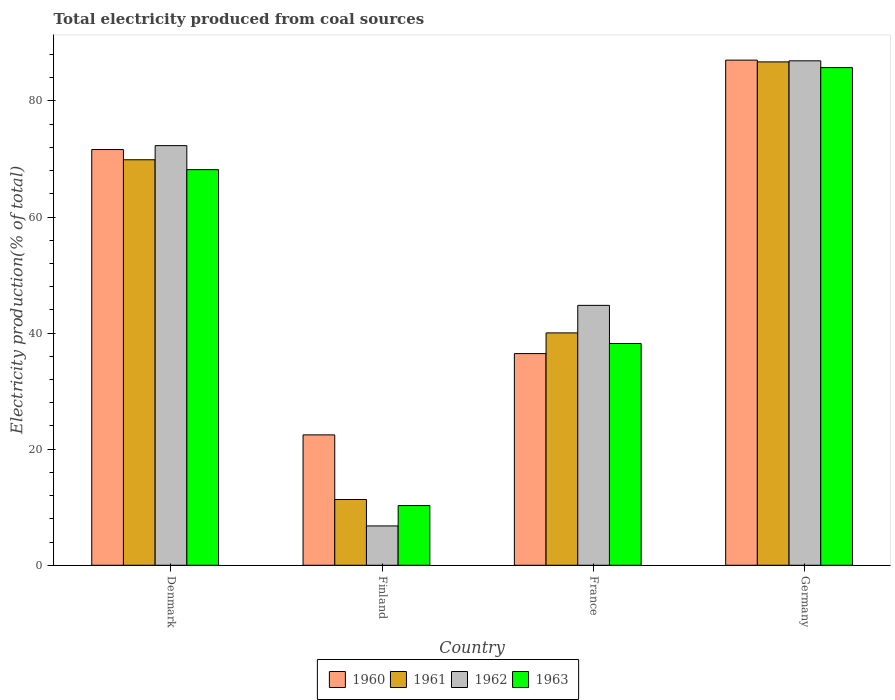How many bars are there on the 4th tick from the left?
Offer a terse response. 4. What is the total electricity produced in 1962 in Germany?
Offer a very short reply. 86.91. Across all countries, what is the maximum total electricity produced in 1962?
Ensure brevity in your answer.  86.91. Across all countries, what is the minimum total electricity produced in 1961?
Provide a succinct answer. 11.33. In which country was the total electricity produced in 1960 maximum?
Your response must be concise. Germany. What is the total total electricity produced in 1962 in the graph?
Provide a short and direct response. 210.76. What is the difference between the total electricity produced in 1962 in Denmark and that in Finland?
Your response must be concise. 65.53. What is the difference between the total electricity produced in 1960 in France and the total electricity produced in 1962 in Finland?
Keep it short and to the point. 29.69. What is the average total electricity produced in 1963 per country?
Offer a very short reply. 50.6. What is the difference between the total electricity produced of/in 1960 and total electricity produced of/in 1963 in Finland?
Your answer should be compact. 12.18. What is the ratio of the total electricity produced in 1962 in Denmark to that in Germany?
Provide a short and direct response. 0.83. Is the total electricity produced in 1962 in Denmark less than that in Finland?
Keep it short and to the point. No. Is the difference between the total electricity produced in 1960 in Finland and France greater than the difference between the total electricity produced in 1963 in Finland and France?
Give a very brief answer. Yes. What is the difference between the highest and the second highest total electricity produced in 1963?
Ensure brevity in your answer.  -17.58. What is the difference between the highest and the lowest total electricity produced in 1963?
Your response must be concise. 75.46. Is the sum of the total electricity produced in 1962 in Finland and France greater than the maximum total electricity produced in 1963 across all countries?
Give a very brief answer. No. What does the 2nd bar from the left in Germany represents?
Offer a very short reply. 1961. Are all the bars in the graph horizontal?
Give a very brief answer. No. How many countries are there in the graph?
Ensure brevity in your answer.  4. How many legend labels are there?
Your response must be concise. 4. How are the legend labels stacked?
Give a very brief answer. Horizontal. What is the title of the graph?
Provide a succinct answer. Total electricity produced from coal sources. What is the label or title of the X-axis?
Give a very brief answer. Country. What is the label or title of the Y-axis?
Make the answer very short. Electricity production(% of total). What is the Electricity production(% of total) of 1960 in Denmark?
Offer a very short reply. 71.62. What is the Electricity production(% of total) in 1961 in Denmark?
Provide a succinct answer. 69.86. What is the Electricity production(% of total) in 1962 in Denmark?
Ensure brevity in your answer.  72.3. What is the Electricity production(% of total) of 1963 in Denmark?
Your answer should be compact. 68.16. What is the Electricity production(% of total) of 1960 in Finland?
Give a very brief answer. 22.46. What is the Electricity production(% of total) in 1961 in Finland?
Your response must be concise. 11.33. What is the Electricity production(% of total) of 1962 in Finland?
Your answer should be compact. 6.78. What is the Electricity production(% of total) of 1963 in Finland?
Offer a very short reply. 10.28. What is the Electricity production(% of total) of 1960 in France?
Keep it short and to the point. 36.47. What is the Electricity production(% of total) in 1961 in France?
Provide a short and direct response. 40.03. What is the Electricity production(% of total) in 1962 in France?
Give a very brief answer. 44.78. What is the Electricity production(% of total) of 1963 in France?
Offer a terse response. 38.21. What is the Electricity production(% of total) of 1960 in Germany?
Your answer should be very brief. 87.03. What is the Electricity production(% of total) in 1961 in Germany?
Provide a succinct answer. 86.73. What is the Electricity production(% of total) in 1962 in Germany?
Provide a succinct answer. 86.91. What is the Electricity production(% of total) in 1963 in Germany?
Give a very brief answer. 85.74. Across all countries, what is the maximum Electricity production(% of total) of 1960?
Offer a very short reply. 87.03. Across all countries, what is the maximum Electricity production(% of total) in 1961?
Provide a short and direct response. 86.73. Across all countries, what is the maximum Electricity production(% of total) in 1962?
Provide a short and direct response. 86.91. Across all countries, what is the maximum Electricity production(% of total) in 1963?
Offer a terse response. 85.74. Across all countries, what is the minimum Electricity production(% of total) of 1960?
Keep it short and to the point. 22.46. Across all countries, what is the minimum Electricity production(% of total) of 1961?
Provide a succinct answer. 11.33. Across all countries, what is the minimum Electricity production(% of total) of 1962?
Make the answer very short. 6.78. Across all countries, what is the minimum Electricity production(% of total) in 1963?
Ensure brevity in your answer.  10.28. What is the total Electricity production(% of total) of 1960 in the graph?
Your answer should be compact. 217.59. What is the total Electricity production(% of total) in 1961 in the graph?
Make the answer very short. 207.95. What is the total Electricity production(% of total) in 1962 in the graph?
Ensure brevity in your answer.  210.76. What is the total Electricity production(% of total) of 1963 in the graph?
Your answer should be very brief. 202.4. What is the difference between the Electricity production(% of total) in 1960 in Denmark and that in Finland?
Your answer should be very brief. 49.16. What is the difference between the Electricity production(% of total) of 1961 in Denmark and that in Finland?
Your answer should be compact. 58.54. What is the difference between the Electricity production(% of total) of 1962 in Denmark and that in Finland?
Your answer should be compact. 65.53. What is the difference between the Electricity production(% of total) in 1963 in Denmark and that in Finland?
Your answer should be very brief. 57.88. What is the difference between the Electricity production(% of total) of 1960 in Denmark and that in France?
Offer a terse response. 35.16. What is the difference between the Electricity production(% of total) in 1961 in Denmark and that in France?
Your answer should be very brief. 29.83. What is the difference between the Electricity production(% of total) of 1962 in Denmark and that in France?
Offer a terse response. 27.52. What is the difference between the Electricity production(% of total) in 1963 in Denmark and that in France?
Your answer should be compact. 29.95. What is the difference between the Electricity production(% of total) of 1960 in Denmark and that in Germany?
Give a very brief answer. -15.4. What is the difference between the Electricity production(% of total) in 1961 in Denmark and that in Germany?
Ensure brevity in your answer.  -16.86. What is the difference between the Electricity production(% of total) in 1962 in Denmark and that in Germany?
Make the answer very short. -14.61. What is the difference between the Electricity production(% of total) in 1963 in Denmark and that in Germany?
Provide a short and direct response. -17.58. What is the difference between the Electricity production(% of total) in 1960 in Finland and that in France?
Give a very brief answer. -14.01. What is the difference between the Electricity production(% of total) in 1961 in Finland and that in France?
Ensure brevity in your answer.  -28.71. What is the difference between the Electricity production(% of total) in 1962 in Finland and that in France?
Keep it short and to the point. -38. What is the difference between the Electricity production(% of total) in 1963 in Finland and that in France?
Ensure brevity in your answer.  -27.93. What is the difference between the Electricity production(% of total) in 1960 in Finland and that in Germany?
Provide a short and direct response. -64.57. What is the difference between the Electricity production(% of total) of 1961 in Finland and that in Germany?
Your answer should be compact. -75.4. What is the difference between the Electricity production(% of total) in 1962 in Finland and that in Germany?
Give a very brief answer. -80.13. What is the difference between the Electricity production(% of total) in 1963 in Finland and that in Germany?
Offer a terse response. -75.46. What is the difference between the Electricity production(% of total) in 1960 in France and that in Germany?
Keep it short and to the point. -50.56. What is the difference between the Electricity production(% of total) in 1961 in France and that in Germany?
Make the answer very short. -46.69. What is the difference between the Electricity production(% of total) of 1962 in France and that in Germany?
Make the answer very short. -42.13. What is the difference between the Electricity production(% of total) of 1963 in France and that in Germany?
Your answer should be very brief. -47.53. What is the difference between the Electricity production(% of total) in 1960 in Denmark and the Electricity production(% of total) in 1961 in Finland?
Ensure brevity in your answer.  60.3. What is the difference between the Electricity production(% of total) of 1960 in Denmark and the Electricity production(% of total) of 1962 in Finland?
Your answer should be compact. 64.85. What is the difference between the Electricity production(% of total) of 1960 in Denmark and the Electricity production(% of total) of 1963 in Finland?
Keep it short and to the point. 61.34. What is the difference between the Electricity production(% of total) of 1961 in Denmark and the Electricity production(% of total) of 1962 in Finland?
Your answer should be compact. 63.09. What is the difference between the Electricity production(% of total) in 1961 in Denmark and the Electricity production(% of total) in 1963 in Finland?
Provide a short and direct response. 59.58. What is the difference between the Electricity production(% of total) of 1962 in Denmark and the Electricity production(% of total) of 1963 in Finland?
Make the answer very short. 62.02. What is the difference between the Electricity production(% of total) in 1960 in Denmark and the Electricity production(% of total) in 1961 in France?
Your answer should be compact. 31.59. What is the difference between the Electricity production(% of total) in 1960 in Denmark and the Electricity production(% of total) in 1962 in France?
Ensure brevity in your answer.  26.85. What is the difference between the Electricity production(% of total) of 1960 in Denmark and the Electricity production(% of total) of 1963 in France?
Make the answer very short. 33.41. What is the difference between the Electricity production(% of total) of 1961 in Denmark and the Electricity production(% of total) of 1962 in France?
Keep it short and to the point. 25.09. What is the difference between the Electricity production(% of total) of 1961 in Denmark and the Electricity production(% of total) of 1963 in France?
Your answer should be compact. 31.65. What is the difference between the Electricity production(% of total) in 1962 in Denmark and the Electricity production(% of total) in 1963 in France?
Provide a short and direct response. 34.09. What is the difference between the Electricity production(% of total) in 1960 in Denmark and the Electricity production(% of total) in 1961 in Germany?
Ensure brevity in your answer.  -15.1. What is the difference between the Electricity production(% of total) of 1960 in Denmark and the Electricity production(% of total) of 1962 in Germany?
Provide a short and direct response. -15.28. What is the difference between the Electricity production(% of total) in 1960 in Denmark and the Electricity production(% of total) in 1963 in Germany?
Your answer should be very brief. -14.12. What is the difference between the Electricity production(% of total) of 1961 in Denmark and the Electricity production(% of total) of 1962 in Germany?
Offer a terse response. -17.04. What is the difference between the Electricity production(% of total) in 1961 in Denmark and the Electricity production(% of total) in 1963 in Germany?
Offer a terse response. -15.88. What is the difference between the Electricity production(% of total) of 1962 in Denmark and the Electricity production(% of total) of 1963 in Germany?
Provide a succinct answer. -13.44. What is the difference between the Electricity production(% of total) in 1960 in Finland and the Electricity production(% of total) in 1961 in France?
Provide a succinct answer. -17.57. What is the difference between the Electricity production(% of total) of 1960 in Finland and the Electricity production(% of total) of 1962 in France?
Keep it short and to the point. -22.31. What is the difference between the Electricity production(% of total) of 1960 in Finland and the Electricity production(% of total) of 1963 in France?
Give a very brief answer. -15.75. What is the difference between the Electricity production(% of total) in 1961 in Finland and the Electricity production(% of total) in 1962 in France?
Make the answer very short. -33.45. What is the difference between the Electricity production(% of total) in 1961 in Finland and the Electricity production(% of total) in 1963 in France?
Offer a very short reply. -26.88. What is the difference between the Electricity production(% of total) in 1962 in Finland and the Electricity production(% of total) in 1963 in France?
Your answer should be compact. -31.44. What is the difference between the Electricity production(% of total) in 1960 in Finland and the Electricity production(% of total) in 1961 in Germany?
Offer a terse response. -64.26. What is the difference between the Electricity production(% of total) of 1960 in Finland and the Electricity production(% of total) of 1962 in Germany?
Your answer should be very brief. -64.45. What is the difference between the Electricity production(% of total) in 1960 in Finland and the Electricity production(% of total) in 1963 in Germany?
Provide a short and direct response. -63.28. What is the difference between the Electricity production(% of total) of 1961 in Finland and the Electricity production(% of total) of 1962 in Germany?
Your answer should be very brief. -75.58. What is the difference between the Electricity production(% of total) of 1961 in Finland and the Electricity production(% of total) of 1963 in Germany?
Your answer should be compact. -74.41. What is the difference between the Electricity production(% of total) of 1962 in Finland and the Electricity production(% of total) of 1963 in Germany?
Offer a very short reply. -78.97. What is the difference between the Electricity production(% of total) of 1960 in France and the Electricity production(% of total) of 1961 in Germany?
Offer a very short reply. -50.26. What is the difference between the Electricity production(% of total) in 1960 in France and the Electricity production(% of total) in 1962 in Germany?
Your response must be concise. -50.44. What is the difference between the Electricity production(% of total) in 1960 in France and the Electricity production(% of total) in 1963 in Germany?
Your answer should be compact. -49.27. What is the difference between the Electricity production(% of total) of 1961 in France and the Electricity production(% of total) of 1962 in Germany?
Your response must be concise. -46.87. What is the difference between the Electricity production(% of total) of 1961 in France and the Electricity production(% of total) of 1963 in Germany?
Provide a short and direct response. -45.71. What is the difference between the Electricity production(% of total) in 1962 in France and the Electricity production(% of total) in 1963 in Germany?
Provide a short and direct response. -40.97. What is the average Electricity production(% of total) of 1960 per country?
Provide a short and direct response. 54.4. What is the average Electricity production(% of total) in 1961 per country?
Offer a terse response. 51.99. What is the average Electricity production(% of total) of 1962 per country?
Your response must be concise. 52.69. What is the average Electricity production(% of total) in 1963 per country?
Your answer should be compact. 50.6. What is the difference between the Electricity production(% of total) in 1960 and Electricity production(% of total) in 1961 in Denmark?
Keep it short and to the point. 1.76. What is the difference between the Electricity production(% of total) of 1960 and Electricity production(% of total) of 1962 in Denmark?
Keep it short and to the point. -0.68. What is the difference between the Electricity production(% of total) in 1960 and Electricity production(% of total) in 1963 in Denmark?
Give a very brief answer. 3.46. What is the difference between the Electricity production(% of total) of 1961 and Electricity production(% of total) of 1962 in Denmark?
Provide a succinct answer. -2.44. What is the difference between the Electricity production(% of total) of 1961 and Electricity production(% of total) of 1963 in Denmark?
Make the answer very short. 1.7. What is the difference between the Electricity production(% of total) in 1962 and Electricity production(% of total) in 1963 in Denmark?
Offer a terse response. 4.14. What is the difference between the Electricity production(% of total) in 1960 and Electricity production(% of total) in 1961 in Finland?
Give a very brief answer. 11.14. What is the difference between the Electricity production(% of total) of 1960 and Electricity production(% of total) of 1962 in Finland?
Provide a succinct answer. 15.69. What is the difference between the Electricity production(% of total) in 1960 and Electricity production(% of total) in 1963 in Finland?
Make the answer very short. 12.18. What is the difference between the Electricity production(% of total) in 1961 and Electricity production(% of total) in 1962 in Finland?
Make the answer very short. 4.55. What is the difference between the Electricity production(% of total) in 1961 and Electricity production(% of total) in 1963 in Finland?
Your response must be concise. 1.04. What is the difference between the Electricity production(% of total) in 1962 and Electricity production(% of total) in 1963 in Finland?
Provide a short and direct response. -3.51. What is the difference between the Electricity production(% of total) of 1960 and Electricity production(% of total) of 1961 in France?
Provide a short and direct response. -3.57. What is the difference between the Electricity production(% of total) in 1960 and Electricity production(% of total) in 1962 in France?
Your answer should be compact. -8.31. What is the difference between the Electricity production(% of total) of 1960 and Electricity production(% of total) of 1963 in France?
Provide a short and direct response. -1.74. What is the difference between the Electricity production(% of total) in 1961 and Electricity production(% of total) in 1962 in France?
Make the answer very short. -4.74. What is the difference between the Electricity production(% of total) in 1961 and Electricity production(% of total) in 1963 in France?
Your answer should be very brief. 1.82. What is the difference between the Electricity production(% of total) of 1962 and Electricity production(% of total) of 1963 in France?
Provide a succinct answer. 6.57. What is the difference between the Electricity production(% of total) of 1960 and Electricity production(% of total) of 1961 in Germany?
Provide a succinct answer. 0.3. What is the difference between the Electricity production(% of total) of 1960 and Electricity production(% of total) of 1962 in Germany?
Ensure brevity in your answer.  0.12. What is the difference between the Electricity production(% of total) in 1960 and Electricity production(% of total) in 1963 in Germany?
Provide a short and direct response. 1.29. What is the difference between the Electricity production(% of total) of 1961 and Electricity production(% of total) of 1962 in Germany?
Provide a succinct answer. -0.18. What is the difference between the Electricity production(% of total) in 1961 and Electricity production(% of total) in 1963 in Germany?
Your answer should be very brief. 0.98. What is the ratio of the Electricity production(% of total) in 1960 in Denmark to that in Finland?
Keep it short and to the point. 3.19. What is the ratio of the Electricity production(% of total) of 1961 in Denmark to that in Finland?
Your response must be concise. 6.17. What is the ratio of the Electricity production(% of total) in 1962 in Denmark to that in Finland?
Ensure brevity in your answer.  10.67. What is the ratio of the Electricity production(% of total) of 1963 in Denmark to that in Finland?
Provide a succinct answer. 6.63. What is the ratio of the Electricity production(% of total) in 1960 in Denmark to that in France?
Your answer should be compact. 1.96. What is the ratio of the Electricity production(% of total) of 1961 in Denmark to that in France?
Keep it short and to the point. 1.75. What is the ratio of the Electricity production(% of total) in 1962 in Denmark to that in France?
Offer a very short reply. 1.61. What is the ratio of the Electricity production(% of total) of 1963 in Denmark to that in France?
Offer a very short reply. 1.78. What is the ratio of the Electricity production(% of total) of 1960 in Denmark to that in Germany?
Your response must be concise. 0.82. What is the ratio of the Electricity production(% of total) in 1961 in Denmark to that in Germany?
Give a very brief answer. 0.81. What is the ratio of the Electricity production(% of total) in 1962 in Denmark to that in Germany?
Provide a short and direct response. 0.83. What is the ratio of the Electricity production(% of total) of 1963 in Denmark to that in Germany?
Keep it short and to the point. 0.79. What is the ratio of the Electricity production(% of total) of 1960 in Finland to that in France?
Your answer should be very brief. 0.62. What is the ratio of the Electricity production(% of total) of 1961 in Finland to that in France?
Provide a short and direct response. 0.28. What is the ratio of the Electricity production(% of total) of 1962 in Finland to that in France?
Your answer should be very brief. 0.15. What is the ratio of the Electricity production(% of total) of 1963 in Finland to that in France?
Ensure brevity in your answer.  0.27. What is the ratio of the Electricity production(% of total) in 1960 in Finland to that in Germany?
Your answer should be compact. 0.26. What is the ratio of the Electricity production(% of total) of 1961 in Finland to that in Germany?
Provide a succinct answer. 0.13. What is the ratio of the Electricity production(% of total) of 1962 in Finland to that in Germany?
Make the answer very short. 0.08. What is the ratio of the Electricity production(% of total) in 1963 in Finland to that in Germany?
Ensure brevity in your answer.  0.12. What is the ratio of the Electricity production(% of total) in 1960 in France to that in Germany?
Keep it short and to the point. 0.42. What is the ratio of the Electricity production(% of total) in 1961 in France to that in Germany?
Keep it short and to the point. 0.46. What is the ratio of the Electricity production(% of total) of 1962 in France to that in Germany?
Provide a succinct answer. 0.52. What is the ratio of the Electricity production(% of total) in 1963 in France to that in Germany?
Offer a terse response. 0.45. What is the difference between the highest and the second highest Electricity production(% of total) in 1960?
Provide a short and direct response. 15.4. What is the difference between the highest and the second highest Electricity production(% of total) of 1961?
Your answer should be compact. 16.86. What is the difference between the highest and the second highest Electricity production(% of total) of 1962?
Provide a short and direct response. 14.61. What is the difference between the highest and the second highest Electricity production(% of total) of 1963?
Provide a short and direct response. 17.58. What is the difference between the highest and the lowest Electricity production(% of total) in 1960?
Offer a terse response. 64.57. What is the difference between the highest and the lowest Electricity production(% of total) in 1961?
Make the answer very short. 75.4. What is the difference between the highest and the lowest Electricity production(% of total) in 1962?
Keep it short and to the point. 80.13. What is the difference between the highest and the lowest Electricity production(% of total) in 1963?
Offer a very short reply. 75.46. 